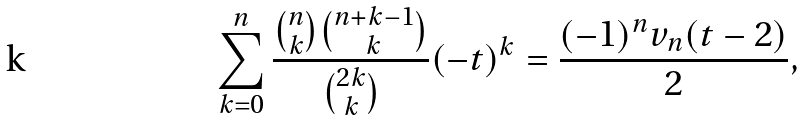Convert formula to latex. <formula><loc_0><loc_0><loc_500><loc_500>\sum _ { k = 0 } ^ { n } \frac { \binom { n } { k } \binom { n + k - 1 } { k } } { \binom { 2 k } { k } } ( - t ) ^ { k } = \frac { ( - 1 ) ^ { n } v _ { n } ( t - 2 ) } { 2 } ,</formula> 